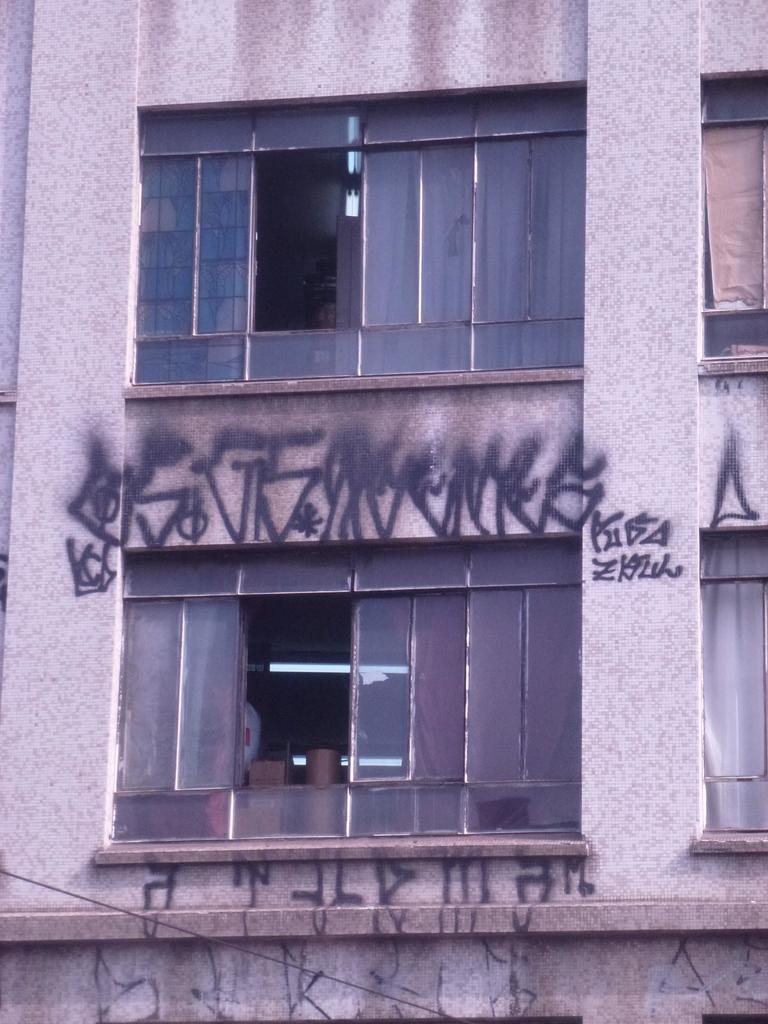Describe this image in one or two sentences. In this image I can see the building with windows. I can see something is written on the building. 